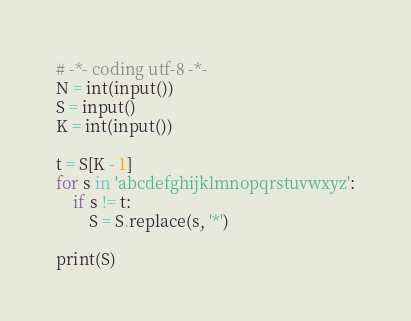Convert code to text. <code><loc_0><loc_0><loc_500><loc_500><_Python_># -*- coding utf-8 -*-
N = int(input())
S = input()
K = int(input())

t = S[K - 1]
for s in 'abcdefghijklmnopqrstuvwxyz':
    if s != t:
        S = S.replace(s, '*')
        
print(S)
</code> 